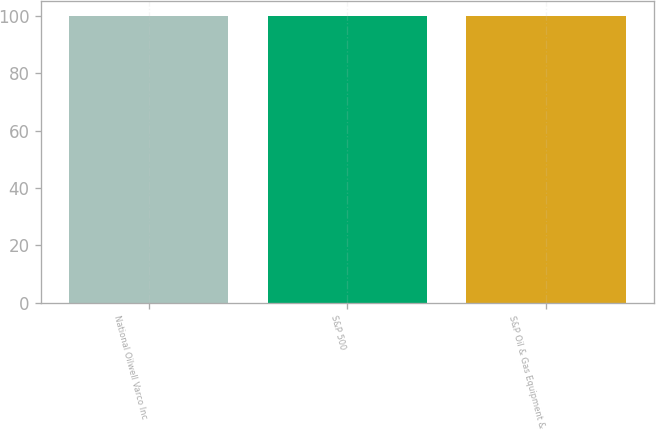Convert chart. <chart><loc_0><loc_0><loc_500><loc_500><bar_chart><fcel>National Oilwell Varco Inc<fcel>S&P 500<fcel>S&P Oil & Gas Equipment &<nl><fcel>100<fcel>100.1<fcel>100.2<nl></chart> 